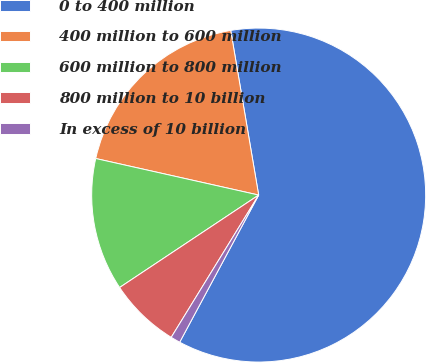Convert chart to OTSL. <chart><loc_0><loc_0><loc_500><loc_500><pie_chart><fcel>0 to 400 million<fcel>400 million to 600 million<fcel>600 million to 800 million<fcel>800 million to 10 billion<fcel>In excess of 10 billion<nl><fcel>60.52%<fcel>18.81%<fcel>12.85%<fcel>6.89%<fcel>0.93%<nl></chart> 